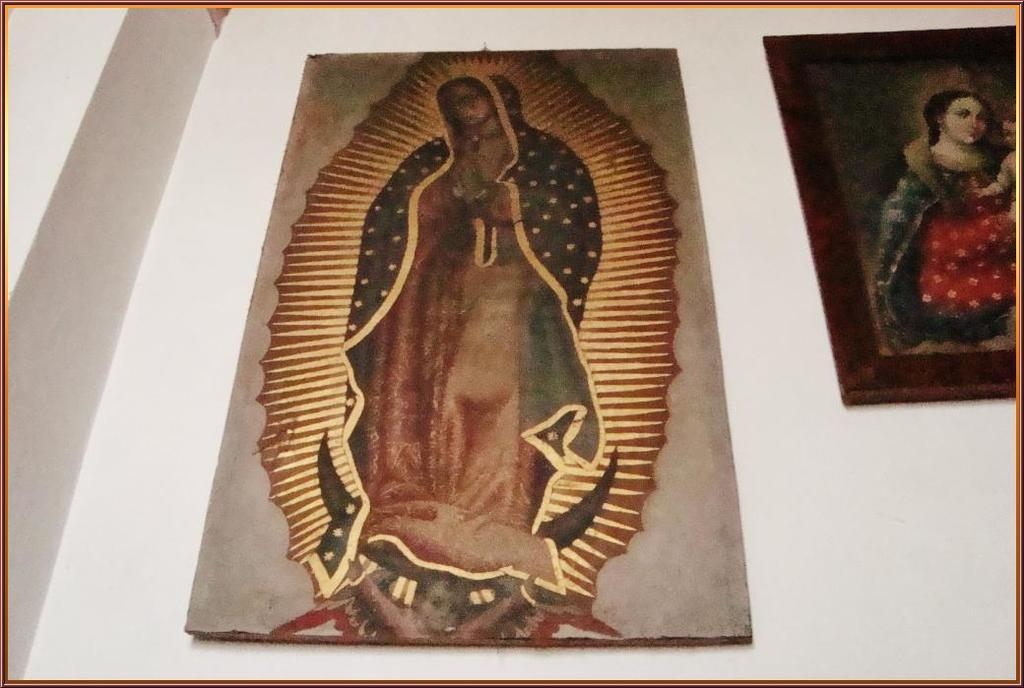What can be seen hanging on the wall in the image? There are frames on the wall in the image. What do the frames contain? The frames contain paintings of a group of people. What is visible behind the frames in the image? There is a wall visible at the back of the image. What type of test is being conducted in the image? There is no test being conducted in the image; it features frames on a wall with paintings of a group of people. What is the nationality of the people depicted in the paintings? The nationality of the people depicted in the paintings cannot be determined from the image alone. 